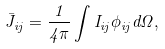Convert formula to latex. <formula><loc_0><loc_0><loc_500><loc_500>\bar { J } _ { i j } = \frac { 1 } { 4 \pi } \int I _ { i j } \phi _ { i j } d \Omega ,</formula> 